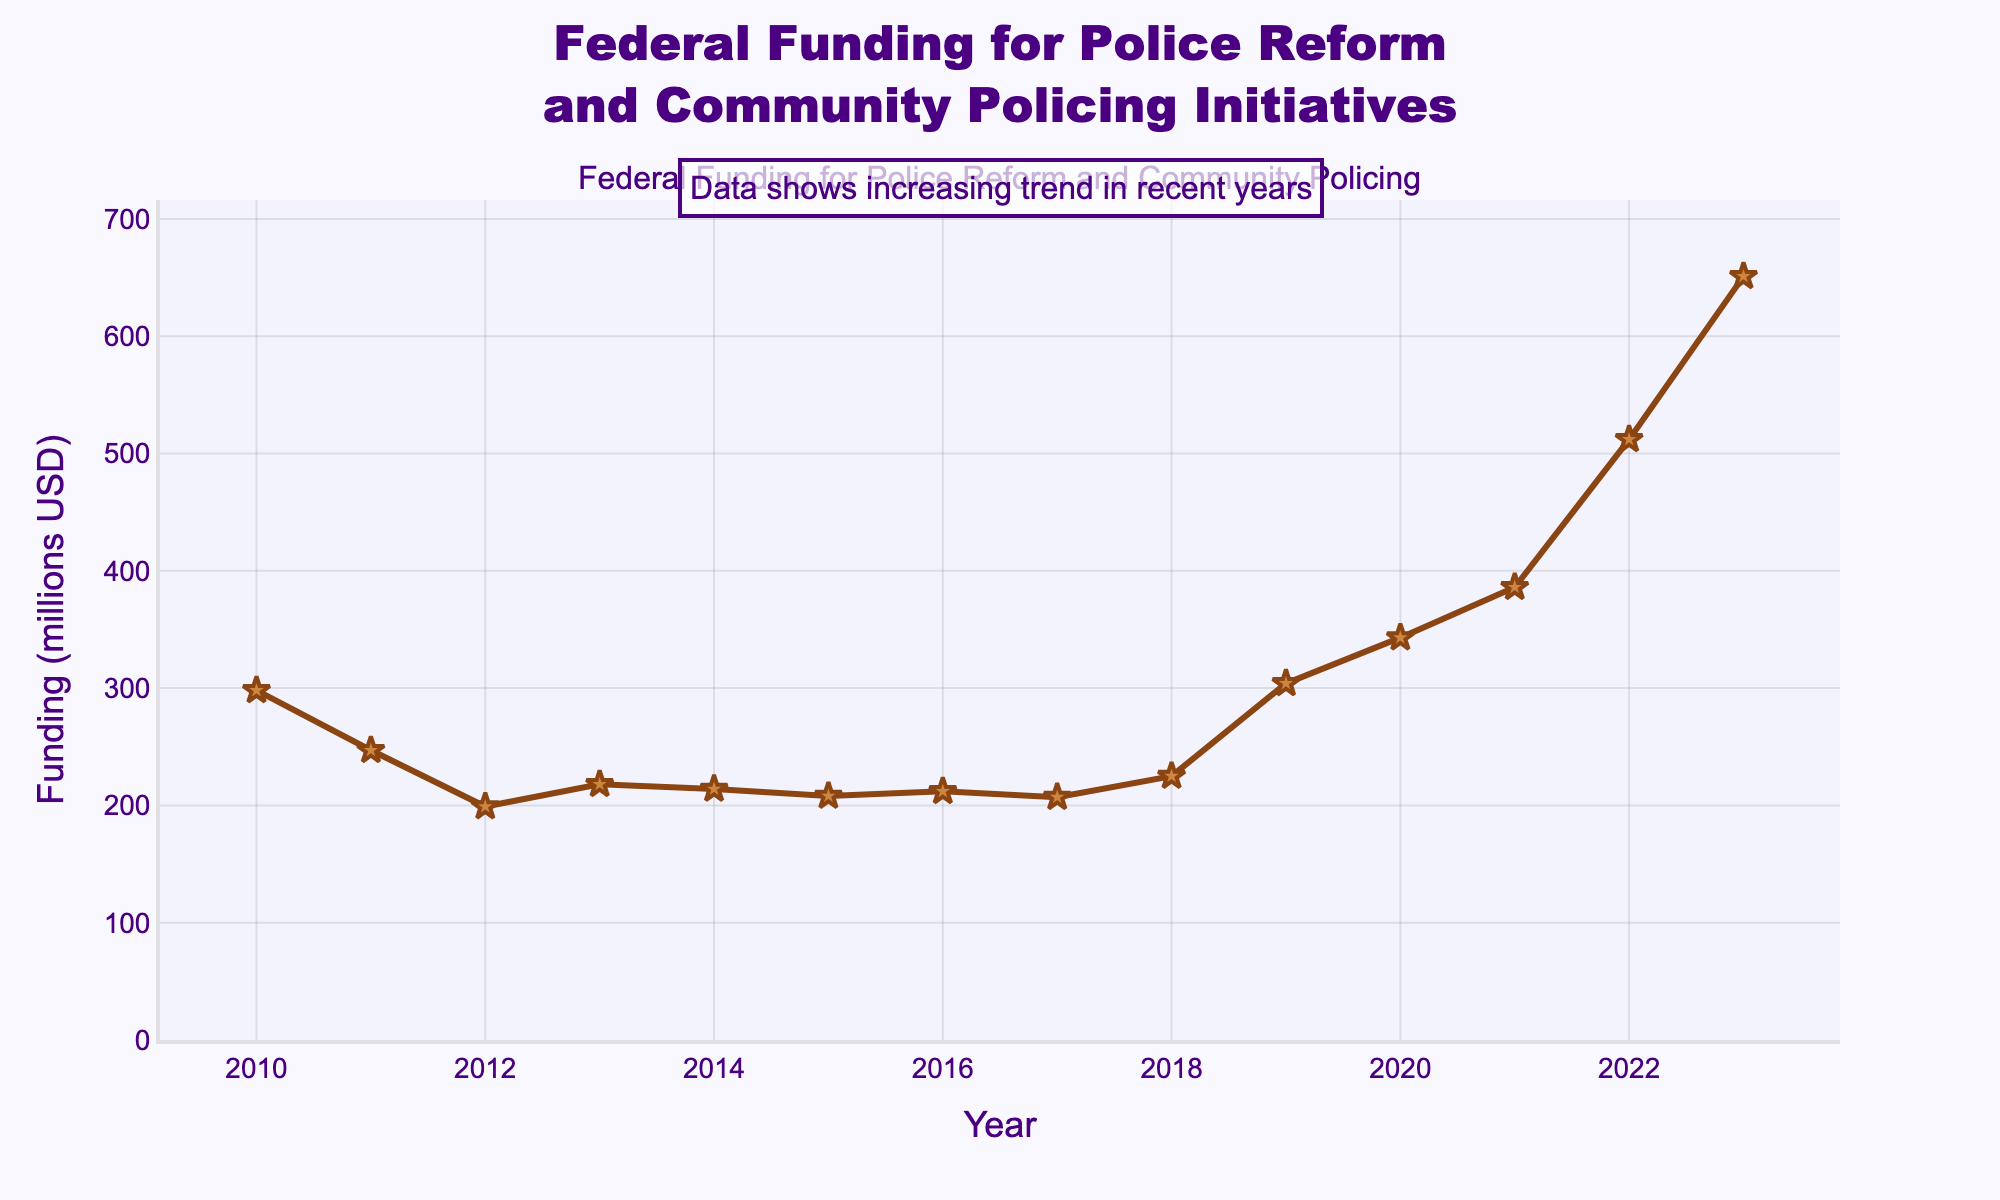Question Explanation
Answer: Concise Answer What is the average federal funding for police reform and community policing initiatives from 2010 to 2023? To calculate the average, sum up all the funding values for each year from 2010 to 2023 and then divide by the number of years (which is 14). Summing the values gives 4544 million USD. So, the average is 4544 / 14 = 324.57 million USD.
Answer: 324.57 million USD Which year had the highest federal funding for police reform and community policing initiatives? By observing the trend line on the chart, the highest funding is seen at the last data point in 2023, which reaches its peak.
Answer: 2023 How much did the funding increase from 2018 to 2023? Looking at the funding values for 2018 and 2023, they are 225 million USD and 651 million USD respectively. The increase is calculated as 651 - 225 = 426 million USD.
Answer: 426 million USD In which year did the funding see the largest single-year decrease? Look for the segment in the plot where the line drops the most steeply. The largest single-year decrease happened between 2010 and 2011, going down from 298 million USD to 247 million USD. The decrease is 298 - 247 = 51 million USD.
Answer: 2011 What is the total funding over the years 2010, 2015, and 2020? Add the funding values for the years 2010, 2015, and 2020. The values are 298, 208, and 343 million USD respectively. Their sum is 298 + 208 + 343 = 849 million USD.
Answer: 849 million USD How many times did the funding amount fall below 210 million USD? By identifying the years where the data points fall below 210 million USD on the plot: these are the years 2012 and 2013. So, it happened twice.
Answer: 2 times During which period did the funding first exceed 300 million USD? Analyzing the chart, the funding first exceeds 300 million USD in 2019.
Answer: 2019 What color represents the funding line on the chart? Observing the line color used in the chart, it is brown.
Answer: Brown Calculate the difference in funding between 2012 and 2020. The funding in 2012 is 199 million USD and in 2020 it is 343 million USD. The difference is calculated as 343 - 199 = 144 million USD.
Answer: 144 million USD What trend can be observed in the data from 2018 to 2023? Observing the chart from 2018 to 2023, there is a noticeable increasing trend in the funding amount.
Answer: Increasing trend 